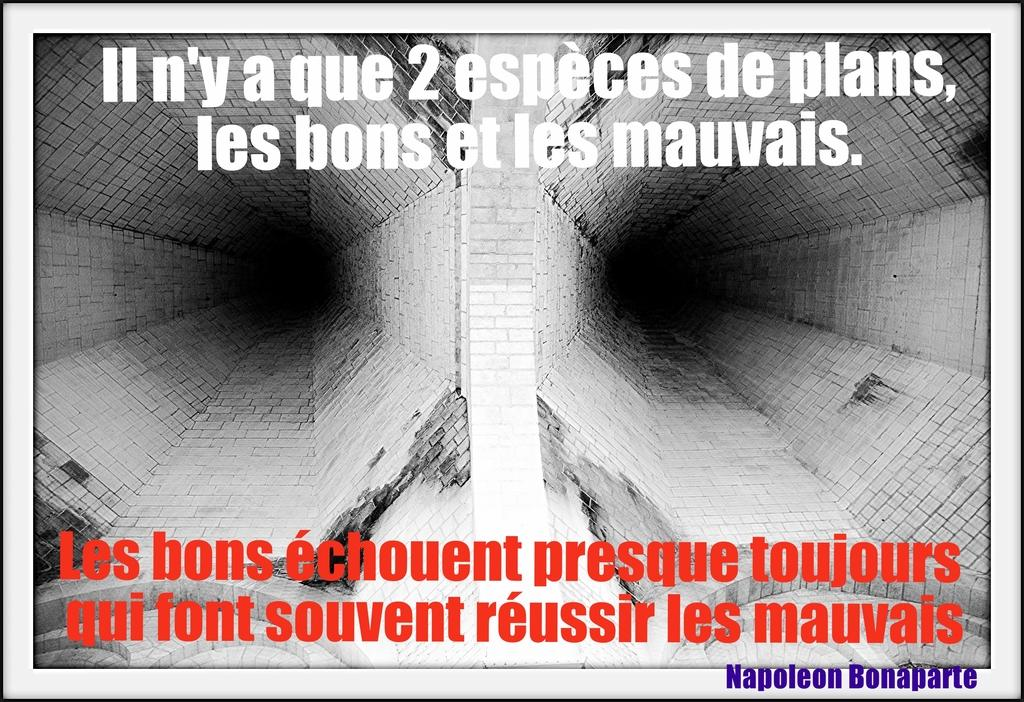<image>
Write a terse but informative summary of the picture. A poster contains a quote from Napoleon Bonaparte on it. 